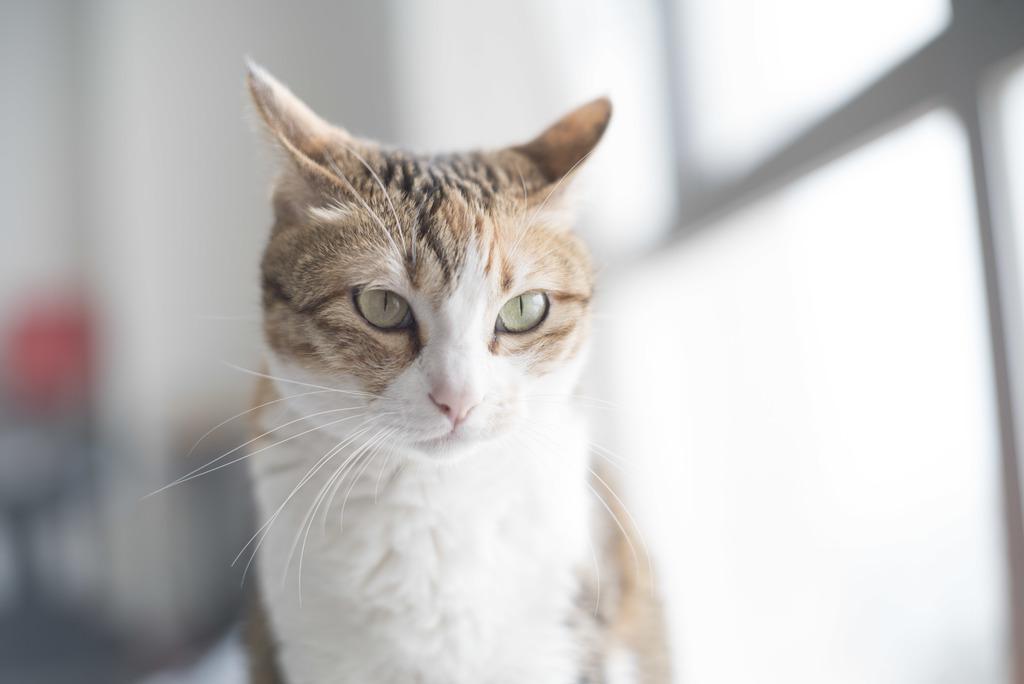How would you summarize this image in a sentence or two? In this picture I can see a cat and I can see blurry background. 